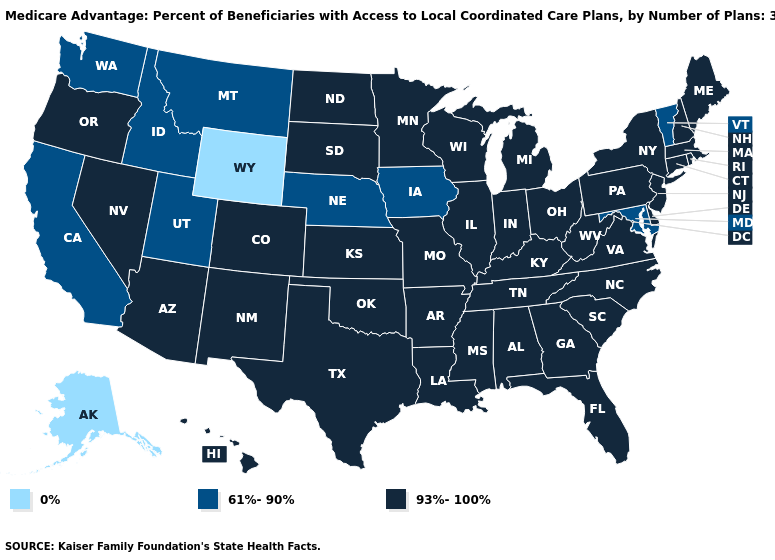What is the value of Montana?
Answer briefly. 61%-90%. Name the states that have a value in the range 93%-100%?
Answer briefly. Colorado, Connecticut, Delaware, Florida, Georgia, Hawaii, Illinois, Indiana, Kansas, Kentucky, Louisiana, Massachusetts, Maine, Michigan, Minnesota, Missouri, Mississippi, North Carolina, North Dakota, New Hampshire, New Jersey, New Mexico, Nevada, New York, Ohio, Oklahoma, Oregon, Pennsylvania, Rhode Island, South Carolina, South Dakota, Tennessee, Texas, Virginia, Wisconsin, West Virginia, Alabama, Arkansas, Arizona. Does Maryland have the same value as Montana?
Be succinct. Yes. What is the value of Iowa?
Short answer required. 61%-90%. What is the highest value in the MidWest ?
Write a very short answer. 93%-100%. What is the highest value in the South ?
Be succinct. 93%-100%. What is the lowest value in the USA?
Quick response, please. 0%. Does Minnesota have a lower value than North Carolina?
Concise answer only. No. Does the map have missing data?
Quick response, please. No. Name the states that have a value in the range 0%?
Keep it brief. Alaska, Wyoming. Which states have the lowest value in the USA?
Quick response, please. Alaska, Wyoming. Does Vermont have the lowest value in the Northeast?
Quick response, please. Yes. Name the states that have a value in the range 93%-100%?
Concise answer only. Colorado, Connecticut, Delaware, Florida, Georgia, Hawaii, Illinois, Indiana, Kansas, Kentucky, Louisiana, Massachusetts, Maine, Michigan, Minnesota, Missouri, Mississippi, North Carolina, North Dakota, New Hampshire, New Jersey, New Mexico, Nevada, New York, Ohio, Oklahoma, Oregon, Pennsylvania, Rhode Island, South Carolina, South Dakota, Tennessee, Texas, Virginia, Wisconsin, West Virginia, Alabama, Arkansas, Arizona. What is the value of North Dakota?
Answer briefly. 93%-100%. Name the states that have a value in the range 0%?
Concise answer only. Alaska, Wyoming. 